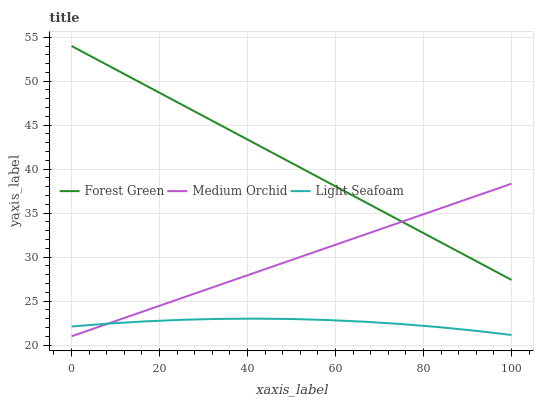Does Light Seafoam have the minimum area under the curve?
Answer yes or no. Yes. Does Medium Orchid have the minimum area under the curve?
Answer yes or no. No. Does Medium Orchid have the maximum area under the curve?
Answer yes or no. No. Is Medium Orchid the smoothest?
Answer yes or no. Yes. Is Light Seafoam the roughest?
Answer yes or no. Yes. Is Light Seafoam the smoothest?
Answer yes or no. No. Is Medium Orchid the roughest?
Answer yes or no. No. Does Light Seafoam have the lowest value?
Answer yes or no. No. Does Medium Orchid have the highest value?
Answer yes or no. No. Is Light Seafoam less than Forest Green?
Answer yes or no. Yes. Is Forest Green greater than Light Seafoam?
Answer yes or no. Yes. Does Light Seafoam intersect Forest Green?
Answer yes or no. No. 